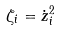<formula> <loc_0><loc_0><loc_500><loc_500>\zeta _ { i } = \dot { z } _ { i } ^ { 2 }</formula> 